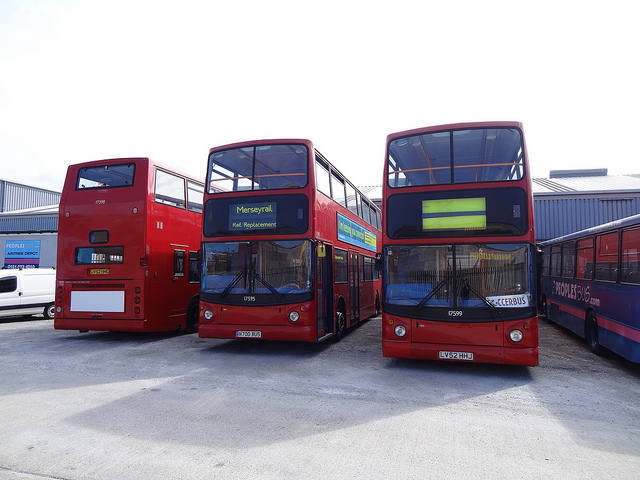Identify and read out the text in this image. CCERBUS 